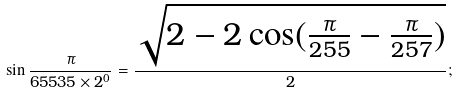Convert formula to latex. <formula><loc_0><loc_0><loc_500><loc_500>\sin { \frac { \pi } { 6 5 5 3 5 \times 2 ^ { 0 } } } = { \frac { \sqrt { 2 - 2 \cos ( { \frac { \pi } { 2 5 5 } } - { \frac { \pi } { 2 5 7 } } ) } } { 2 } } ;</formula> 